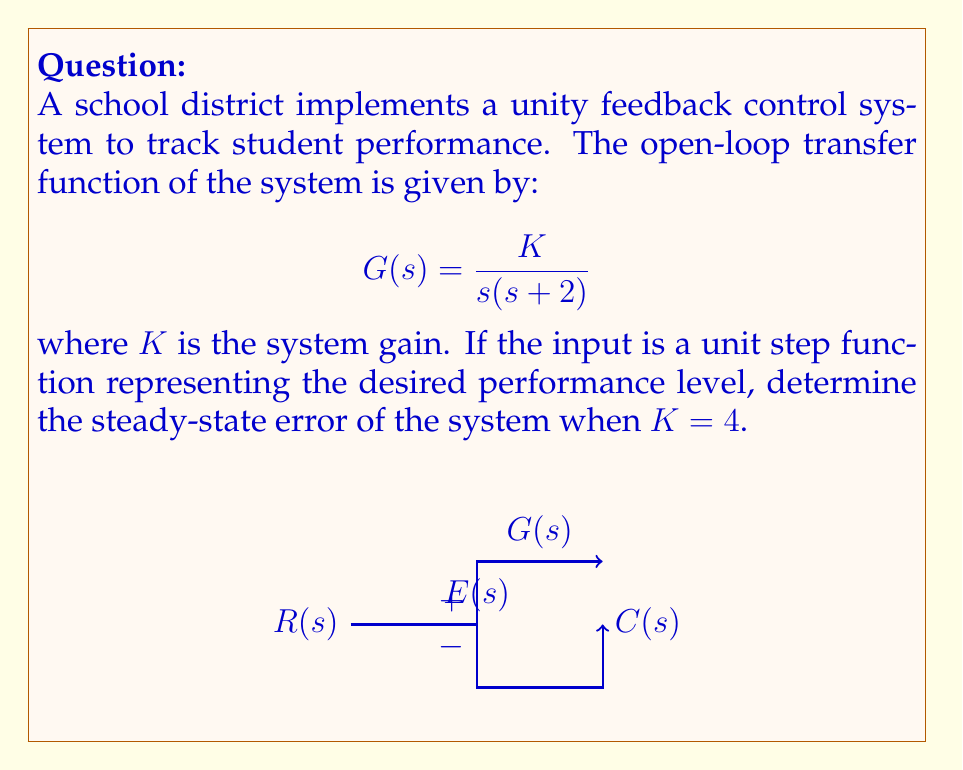Teach me how to tackle this problem. To determine the steady-state error for a unity feedback control system with a step input, we can follow these steps:

1) The steady-state error for a step input is given by:

   $$e_{ss} = \lim_{s \to 0} \frac{s}{1 + G(s)}$$

2) Substitute the given transfer function:

   $$e_{ss} = \lim_{s \to 0} \frac{s}{1 + \frac{K}{s(s+2)}}$$

3) Multiply numerator and denominator by $s(s+2)$:

   $$e_{ss} = \lim_{s \to 0} \frac{s^2(s+2)}{s(s+2) + K}$$

4) Expand the denominator:

   $$e_{ss} = \lim_{s \to 0} \frac{s^3 + 2s^2}{s^2 + 2s + K}$$

5) As $s \to 0$, the higher order terms approach zero:

   $$e_{ss} = \frac{0 + 0}{0 + 0 + K} = \frac{0}{K}$$

6) Substitute the given value of $K = 4$:

   $$e_{ss} = \frac{0}{4} = 0$$

Therefore, the steady-state error of the system is zero, indicating that the system will track the desired performance level perfectly in the steady state.
Answer: 0 